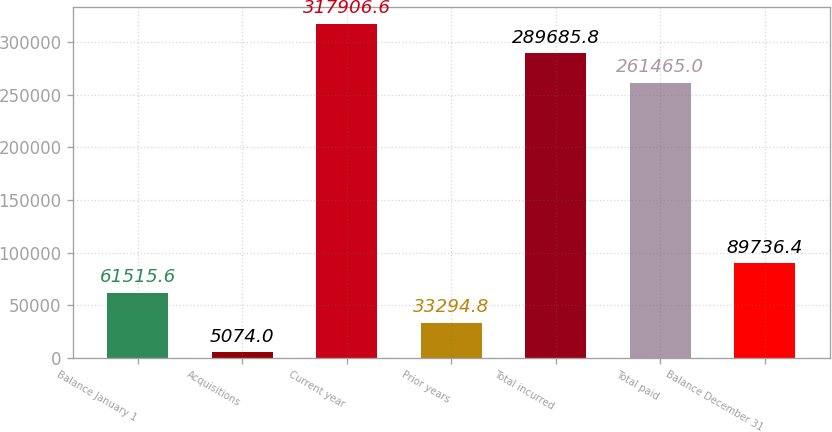Convert chart to OTSL. <chart><loc_0><loc_0><loc_500><loc_500><bar_chart><fcel>Balance January 1<fcel>Acquisitions<fcel>Current year<fcel>Prior years<fcel>Total incurred<fcel>Total paid<fcel>Balance December 31<nl><fcel>61515.6<fcel>5074<fcel>317907<fcel>33294.8<fcel>289686<fcel>261465<fcel>89736.4<nl></chart> 